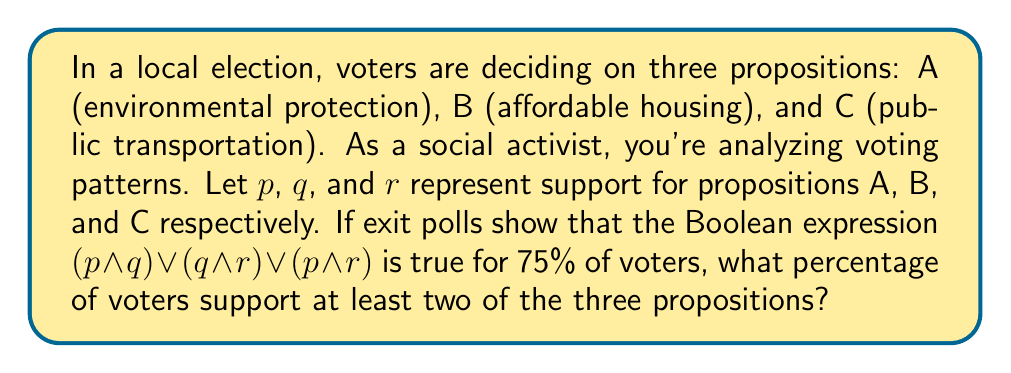Solve this math problem. Let's approach this step-by-step:

1) The Boolean expression $(p \land q) \lor (q \land r) \lor (p \land r)$ represents voters who support at least two of the three propositions.

2) This is because:
   - $(p \land q)$ represents voters who support both A and B
   - $(q \land r)$ represents voters who support both B and C
   - $(p \land r)$ represents voters who support both A and C

3) The 'or' ($\lor$) between these terms means that if any of these conditions are true, the whole expression is true.

4) We're told that this expression is true for 75% of voters.

5) Therefore, 75% of voters support at least two of the three propositions.

6) The question asks for the percentage of voters who support at least two propositions, which is exactly what we've calculated.

Thus, the percentage of voters who support at least two of the three propositions is 75%.
Answer: 75% 